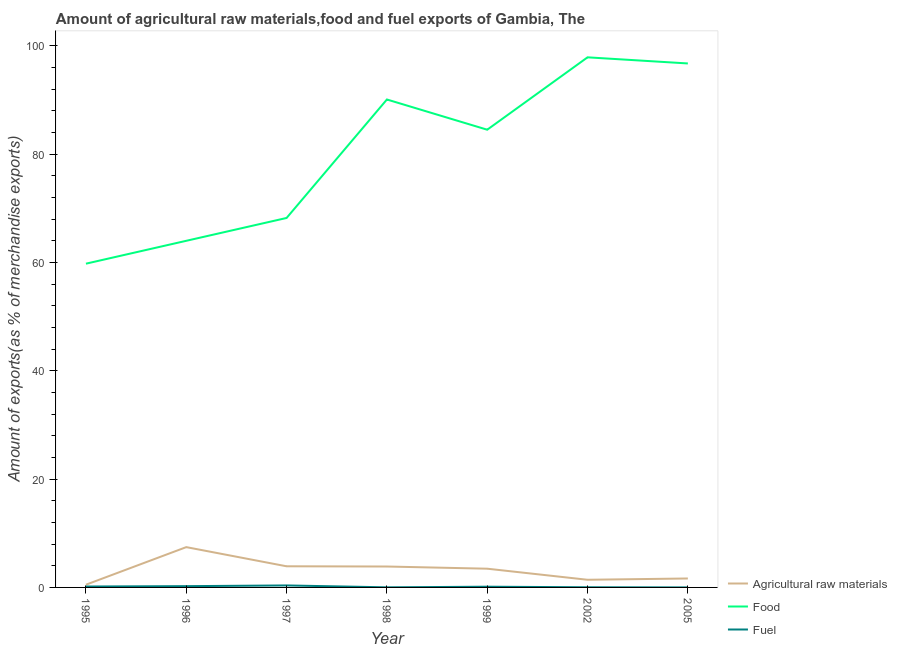Does the line corresponding to percentage of fuel exports intersect with the line corresponding to percentage of food exports?
Give a very brief answer. No. Is the number of lines equal to the number of legend labels?
Make the answer very short. Yes. What is the percentage of fuel exports in 1995?
Keep it short and to the point. 0.17. Across all years, what is the maximum percentage of fuel exports?
Your answer should be compact. 0.37. Across all years, what is the minimum percentage of raw materials exports?
Give a very brief answer. 0.5. In which year was the percentage of raw materials exports maximum?
Make the answer very short. 1996. What is the total percentage of raw materials exports in the graph?
Offer a terse response. 22.23. What is the difference between the percentage of fuel exports in 1999 and that in 2002?
Give a very brief answer. 0.1. What is the difference between the percentage of raw materials exports in 1997 and the percentage of food exports in 2002?
Provide a short and direct response. -93.96. What is the average percentage of raw materials exports per year?
Offer a very short reply. 3.18. In the year 2005, what is the difference between the percentage of food exports and percentage of fuel exports?
Offer a very short reply. 96.73. In how many years, is the percentage of fuel exports greater than 76 %?
Offer a very short reply. 0. What is the ratio of the percentage of fuel exports in 1996 to that in 1997?
Your answer should be compact. 0.64. Is the difference between the percentage of raw materials exports in 2002 and 2005 greater than the difference between the percentage of fuel exports in 2002 and 2005?
Offer a very short reply. No. What is the difference between the highest and the second highest percentage of food exports?
Your answer should be compact. 1.13. What is the difference between the highest and the lowest percentage of food exports?
Make the answer very short. 38.1. In how many years, is the percentage of food exports greater than the average percentage of food exports taken over all years?
Ensure brevity in your answer.  4. Is the sum of the percentage of fuel exports in 1997 and 1999 greater than the maximum percentage of raw materials exports across all years?
Make the answer very short. No. Is the percentage of food exports strictly greater than the percentage of fuel exports over the years?
Provide a short and direct response. Yes. How many lines are there?
Offer a terse response. 3. What is the difference between two consecutive major ticks on the Y-axis?
Your response must be concise. 20. Are the values on the major ticks of Y-axis written in scientific E-notation?
Give a very brief answer. No. Does the graph contain any zero values?
Your answer should be very brief. No. Does the graph contain grids?
Make the answer very short. No. How many legend labels are there?
Make the answer very short. 3. What is the title of the graph?
Offer a very short reply. Amount of agricultural raw materials,food and fuel exports of Gambia, The. What is the label or title of the Y-axis?
Keep it short and to the point. Amount of exports(as % of merchandise exports). What is the Amount of exports(as % of merchandise exports) of Agricultural raw materials in 1995?
Make the answer very short. 0.5. What is the Amount of exports(as % of merchandise exports) of Food in 1995?
Offer a very short reply. 59.77. What is the Amount of exports(as % of merchandise exports) in Fuel in 1995?
Make the answer very short. 0.17. What is the Amount of exports(as % of merchandise exports) of Agricultural raw materials in 1996?
Keep it short and to the point. 7.44. What is the Amount of exports(as % of merchandise exports) in Food in 1996?
Your answer should be compact. 63.99. What is the Amount of exports(as % of merchandise exports) in Fuel in 1996?
Your response must be concise. 0.24. What is the Amount of exports(as % of merchandise exports) in Agricultural raw materials in 1997?
Offer a very short reply. 3.9. What is the Amount of exports(as % of merchandise exports) of Food in 1997?
Provide a short and direct response. 68.21. What is the Amount of exports(as % of merchandise exports) in Fuel in 1997?
Your response must be concise. 0.37. What is the Amount of exports(as % of merchandise exports) of Agricultural raw materials in 1998?
Your answer should be compact. 3.86. What is the Amount of exports(as % of merchandise exports) in Food in 1998?
Offer a very short reply. 90.08. What is the Amount of exports(as % of merchandise exports) in Fuel in 1998?
Offer a very short reply. 0.02. What is the Amount of exports(as % of merchandise exports) in Agricultural raw materials in 1999?
Provide a short and direct response. 3.46. What is the Amount of exports(as % of merchandise exports) in Food in 1999?
Offer a very short reply. 84.5. What is the Amount of exports(as % of merchandise exports) in Fuel in 1999?
Ensure brevity in your answer.  0.13. What is the Amount of exports(as % of merchandise exports) in Agricultural raw materials in 2002?
Ensure brevity in your answer.  1.41. What is the Amount of exports(as % of merchandise exports) in Food in 2002?
Give a very brief answer. 97.86. What is the Amount of exports(as % of merchandise exports) of Fuel in 2002?
Offer a very short reply. 0.03. What is the Amount of exports(as % of merchandise exports) in Agricultural raw materials in 2005?
Your response must be concise. 1.65. What is the Amount of exports(as % of merchandise exports) in Food in 2005?
Your answer should be compact. 96.73. What is the Amount of exports(as % of merchandise exports) of Fuel in 2005?
Ensure brevity in your answer.  0. Across all years, what is the maximum Amount of exports(as % of merchandise exports) in Agricultural raw materials?
Provide a succinct answer. 7.44. Across all years, what is the maximum Amount of exports(as % of merchandise exports) in Food?
Your answer should be compact. 97.86. Across all years, what is the maximum Amount of exports(as % of merchandise exports) in Fuel?
Keep it short and to the point. 0.37. Across all years, what is the minimum Amount of exports(as % of merchandise exports) in Agricultural raw materials?
Make the answer very short. 0.5. Across all years, what is the minimum Amount of exports(as % of merchandise exports) of Food?
Your answer should be very brief. 59.77. Across all years, what is the minimum Amount of exports(as % of merchandise exports) of Fuel?
Provide a succinct answer. 0. What is the total Amount of exports(as % of merchandise exports) of Agricultural raw materials in the graph?
Ensure brevity in your answer.  22.23. What is the total Amount of exports(as % of merchandise exports) of Food in the graph?
Give a very brief answer. 561.15. What is the total Amount of exports(as % of merchandise exports) of Fuel in the graph?
Give a very brief answer. 0.96. What is the difference between the Amount of exports(as % of merchandise exports) of Agricultural raw materials in 1995 and that in 1996?
Offer a very short reply. -6.94. What is the difference between the Amount of exports(as % of merchandise exports) in Food in 1995 and that in 1996?
Offer a terse response. -4.22. What is the difference between the Amount of exports(as % of merchandise exports) in Fuel in 1995 and that in 1996?
Offer a very short reply. -0.07. What is the difference between the Amount of exports(as % of merchandise exports) of Agricultural raw materials in 1995 and that in 1997?
Ensure brevity in your answer.  -3.4. What is the difference between the Amount of exports(as % of merchandise exports) of Food in 1995 and that in 1997?
Keep it short and to the point. -8.44. What is the difference between the Amount of exports(as % of merchandise exports) of Fuel in 1995 and that in 1997?
Ensure brevity in your answer.  -0.2. What is the difference between the Amount of exports(as % of merchandise exports) of Agricultural raw materials in 1995 and that in 1998?
Your answer should be very brief. -3.36. What is the difference between the Amount of exports(as % of merchandise exports) of Food in 1995 and that in 1998?
Give a very brief answer. -30.31. What is the difference between the Amount of exports(as % of merchandise exports) of Fuel in 1995 and that in 1998?
Make the answer very short. 0.15. What is the difference between the Amount of exports(as % of merchandise exports) of Agricultural raw materials in 1995 and that in 1999?
Your answer should be very brief. -2.95. What is the difference between the Amount of exports(as % of merchandise exports) of Food in 1995 and that in 1999?
Offer a terse response. -24.73. What is the difference between the Amount of exports(as % of merchandise exports) in Fuel in 1995 and that in 1999?
Offer a very short reply. 0.04. What is the difference between the Amount of exports(as % of merchandise exports) of Agricultural raw materials in 1995 and that in 2002?
Your response must be concise. -0.91. What is the difference between the Amount of exports(as % of merchandise exports) in Food in 1995 and that in 2002?
Provide a short and direct response. -38.1. What is the difference between the Amount of exports(as % of merchandise exports) in Fuel in 1995 and that in 2002?
Ensure brevity in your answer.  0.14. What is the difference between the Amount of exports(as % of merchandise exports) of Agricultural raw materials in 1995 and that in 2005?
Provide a succinct answer. -1.15. What is the difference between the Amount of exports(as % of merchandise exports) in Food in 1995 and that in 2005?
Your answer should be very brief. -36.97. What is the difference between the Amount of exports(as % of merchandise exports) in Fuel in 1995 and that in 2005?
Give a very brief answer. 0.17. What is the difference between the Amount of exports(as % of merchandise exports) in Agricultural raw materials in 1996 and that in 1997?
Offer a very short reply. 3.54. What is the difference between the Amount of exports(as % of merchandise exports) in Food in 1996 and that in 1997?
Your answer should be compact. -4.22. What is the difference between the Amount of exports(as % of merchandise exports) in Fuel in 1996 and that in 1997?
Offer a very short reply. -0.13. What is the difference between the Amount of exports(as % of merchandise exports) in Agricultural raw materials in 1996 and that in 1998?
Provide a short and direct response. 3.58. What is the difference between the Amount of exports(as % of merchandise exports) in Food in 1996 and that in 1998?
Make the answer very short. -26.09. What is the difference between the Amount of exports(as % of merchandise exports) in Fuel in 1996 and that in 1998?
Your answer should be compact. 0.22. What is the difference between the Amount of exports(as % of merchandise exports) of Agricultural raw materials in 1996 and that in 1999?
Offer a very short reply. 3.98. What is the difference between the Amount of exports(as % of merchandise exports) of Food in 1996 and that in 1999?
Offer a very short reply. -20.51. What is the difference between the Amount of exports(as % of merchandise exports) in Fuel in 1996 and that in 1999?
Ensure brevity in your answer.  0.1. What is the difference between the Amount of exports(as % of merchandise exports) in Agricultural raw materials in 1996 and that in 2002?
Provide a short and direct response. 6.03. What is the difference between the Amount of exports(as % of merchandise exports) of Food in 1996 and that in 2002?
Offer a very short reply. -33.87. What is the difference between the Amount of exports(as % of merchandise exports) of Fuel in 1996 and that in 2002?
Make the answer very short. 0.21. What is the difference between the Amount of exports(as % of merchandise exports) in Agricultural raw materials in 1996 and that in 2005?
Your answer should be very brief. 5.79. What is the difference between the Amount of exports(as % of merchandise exports) in Food in 1996 and that in 2005?
Offer a terse response. -32.74. What is the difference between the Amount of exports(as % of merchandise exports) in Fuel in 1996 and that in 2005?
Your response must be concise. 0.23. What is the difference between the Amount of exports(as % of merchandise exports) of Agricultural raw materials in 1997 and that in 1998?
Your response must be concise. 0.04. What is the difference between the Amount of exports(as % of merchandise exports) in Food in 1997 and that in 1998?
Provide a short and direct response. -21.87. What is the difference between the Amount of exports(as % of merchandise exports) of Fuel in 1997 and that in 1998?
Provide a short and direct response. 0.35. What is the difference between the Amount of exports(as % of merchandise exports) of Agricultural raw materials in 1997 and that in 1999?
Provide a short and direct response. 0.44. What is the difference between the Amount of exports(as % of merchandise exports) in Food in 1997 and that in 1999?
Provide a succinct answer. -16.29. What is the difference between the Amount of exports(as % of merchandise exports) in Fuel in 1997 and that in 1999?
Make the answer very short. 0.23. What is the difference between the Amount of exports(as % of merchandise exports) in Agricultural raw materials in 1997 and that in 2002?
Your answer should be very brief. 2.49. What is the difference between the Amount of exports(as % of merchandise exports) in Food in 1997 and that in 2002?
Provide a short and direct response. -29.66. What is the difference between the Amount of exports(as % of merchandise exports) in Fuel in 1997 and that in 2002?
Make the answer very short. 0.34. What is the difference between the Amount of exports(as % of merchandise exports) in Agricultural raw materials in 1997 and that in 2005?
Make the answer very short. 2.25. What is the difference between the Amount of exports(as % of merchandise exports) in Food in 1997 and that in 2005?
Offer a very short reply. -28.53. What is the difference between the Amount of exports(as % of merchandise exports) of Fuel in 1997 and that in 2005?
Your answer should be compact. 0.36. What is the difference between the Amount of exports(as % of merchandise exports) of Agricultural raw materials in 1998 and that in 1999?
Offer a terse response. 0.4. What is the difference between the Amount of exports(as % of merchandise exports) of Food in 1998 and that in 1999?
Your response must be concise. 5.58. What is the difference between the Amount of exports(as % of merchandise exports) of Fuel in 1998 and that in 1999?
Ensure brevity in your answer.  -0.12. What is the difference between the Amount of exports(as % of merchandise exports) of Agricultural raw materials in 1998 and that in 2002?
Provide a short and direct response. 2.45. What is the difference between the Amount of exports(as % of merchandise exports) in Food in 1998 and that in 2002?
Make the answer very short. -7.78. What is the difference between the Amount of exports(as % of merchandise exports) of Fuel in 1998 and that in 2002?
Provide a short and direct response. -0.01. What is the difference between the Amount of exports(as % of merchandise exports) of Agricultural raw materials in 1998 and that in 2005?
Provide a short and direct response. 2.21. What is the difference between the Amount of exports(as % of merchandise exports) of Food in 1998 and that in 2005?
Ensure brevity in your answer.  -6.65. What is the difference between the Amount of exports(as % of merchandise exports) in Fuel in 1998 and that in 2005?
Provide a succinct answer. 0.01. What is the difference between the Amount of exports(as % of merchandise exports) of Agricultural raw materials in 1999 and that in 2002?
Give a very brief answer. 2.04. What is the difference between the Amount of exports(as % of merchandise exports) of Food in 1999 and that in 2002?
Offer a very short reply. -13.36. What is the difference between the Amount of exports(as % of merchandise exports) in Fuel in 1999 and that in 2002?
Offer a terse response. 0.1. What is the difference between the Amount of exports(as % of merchandise exports) in Agricultural raw materials in 1999 and that in 2005?
Make the answer very short. 1.81. What is the difference between the Amount of exports(as % of merchandise exports) in Food in 1999 and that in 2005?
Your answer should be very brief. -12.23. What is the difference between the Amount of exports(as % of merchandise exports) in Fuel in 1999 and that in 2005?
Your response must be concise. 0.13. What is the difference between the Amount of exports(as % of merchandise exports) in Agricultural raw materials in 2002 and that in 2005?
Offer a terse response. -0.24. What is the difference between the Amount of exports(as % of merchandise exports) in Food in 2002 and that in 2005?
Provide a succinct answer. 1.13. What is the difference between the Amount of exports(as % of merchandise exports) of Fuel in 2002 and that in 2005?
Ensure brevity in your answer.  0.03. What is the difference between the Amount of exports(as % of merchandise exports) of Agricultural raw materials in 1995 and the Amount of exports(as % of merchandise exports) of Food in 1996?
Make the answer very short. -63.49. What is the difference between the Amount of exports(as % of merchandise exports) of Agricultural raw materials in 1995 and the Amount of exports(as % of merchandise exports) of Fuel in 1996?
Offer a very short reply. 0.27. What is the difference between the Amount of exports(as % of merchandise exports) in Food in 1995 and the Amount of exports(as % of merchandise exports) in Fuel in 1996?
Your answer should be very brief. 59.53. What is the difference between the Amount of exports(as % of merchandise exports) of Agricultural raw materials in 1995 and the Amount of exports(as % of merchandise exports) of Food in 1997?
Offer a very short reply. -67.7. What is the difference between the Amount of exports(as % of merchandise exports) of Agricultural raw materials in 1995 and the Amount of exports(as % of merchandise exports) of Fuel in 1997?
Your answer should be very brief. 0.14. What is the difference between the Amount of exports(as % of merchandise exports) in Food in 1995 and the Amount of exports(as % of merchandise exports) in Fuel in 1997?
Give a very brief answer. 59.4. What is the difference between the Amount of exports(as % of merchandise exports) of Agricultural raw materials in 1995 and the Amount of exports(as % of merchandise exports) of Food in 1998?
Provide a succinct answer. -89.58. What is the difference between the Amount of exports(as % of merchandise exports) in Agricultural raw materials in 1995 and the Amount of exports(as % of merchandise exports) in Fuel in 1998?
Offer a very short reply. 0.49. What is the difference between the Amount of exports(as % of merchandise exports) in Food in 1995 and the Amount of exports(as % of merchandise exports) in Fuel in 1998?
Offer a very short reply. 59.75. What is the difference between the Amount of exports(as % of merchandise exports) of Agricultural raw materials in 1995 and the Amount of exports(as % of merchandise exports) of Food in 1999?
Provide a succinct answer. -84. What is the difference between the Amount of exports(as % of merchandise exports) of Agricultural raw materials in 1995 and the Amount of exports(as % of merchandise exports) of Fuel in 1999?
Make the answer very short. 0.37. What is the difference between the Amount of exports(as % of merchandise exports) in Food in 1995 and the Amount of exports(as % of merchandise exports) in Fuel in 1999?
Offer a very short reply. 59.64. What is the difference between the Amount of exports(as % of merchandise exports) in Agricultural raw materials in 1995 and the Amount of exports(as % of merchandise exports) in Food in 2002?
Your response must be concise. -97.36. What is the difference between the Amount of exports(as % of merchandise exports) of Agricultural raw materials in 1995 and the Amount of exports(as % of merchandise exports) of Fuel in 2002?
Your answer should be compact. 0.47. What is the difference between the Amount of exports(as % of merchandise exports) in Food in 1995 and the Amount of exports(as % of merchandise exports) in Fuel in 2002?
Your answer should be very brief. 59.74. What is the difference between the Amount of exports(as % of merchandise exports) in Agricultural raw materials in 1995 and the Amount of exports(as % of merchandise exports) in Food in 2005?
Your response must be concise. -96.23. What is the difference between the Amount of exports(as % of merchandise exports) in Agricultural raw materials in 1995 and the Amount of exports(as % of merchandise exports) in Fuel in 2005?
Provide a short and direct response. 0.5. What is the difference between the Amount of exports(as % of merchandise exports) in Food in 1995 and the Amount of exports(as % of merchandise exports) in Fuel in 2005?
Provide a succinct answer. 59.77. What is the difference between the Amount of exports(as % of merchandise exports) in Agricultural raw materials in 1996 and the Amount of exports(as % of merchandise exports) in Food in 1997?
Keep it short and to the point. -60.77. What is the difference between the Amount of exports(as % of merchandise exports) in Agricultural raw materials in 1996 and the Amount of exports(as % of merchandise exports) in Fuel in 1997?
Make the answer very short. 7.07. What is the difference between the Amount of exports(as % of merchandise exports) of Food in 1996 and the Amount of exports(as % of merchandise exports) of Fuel in 1997?
Offer a terse response. 63.62. What is the difference between the Amount of exports(as % of merchandise exports) of Agricultural raw materials in 1996 and the Amount of exports(as % of merchandise exports) of Food in 1998?
Offer a terse response. -82.64. What is the difference between the Amount of exports(as % of merchandise exports) in Agricultural raw materials in 1996 and the Amount of exports(as % of merchandise exports) in Fuel in 1998?
Your response must be concise. 7.42. What is the difference between the Amount of exports(as % of merchandise exports) of Food in 1996 and the Amount of exports(as % of merchandise exports) of Fuel in 1998?
Make the answer very short. 63.97. What is the difference between the Amount of exports(as % of merchandise exports) in Agricultural raw materials in 1996 and the Amount of exports(as % of merchandise exports) in Food in 1999?
Offer a terse response. -77.06. What is the difference between the Amount of exports(as % of merchandise exports) in Agricultural raw materials in 1996 and the Amount of exports(as % of merchandise exports) in Fuel in 1999?
Ensure brevity in your answer.  7.31. What is the difference between the Amount of exports(as % of merchandise exports) of Food in 1996 and the Amount of exports(as % of merchandise exports) of Fuel in 1999?
Offer a terse response. 63.86. What is the difference between the Amount of exports(as % of merchandise exports) of Agricultural raw materials in 1996 and the Amount of exports(as % of merchandise exports) of Food in 2002?
Keep it short and to the point. -90.43. What is the difference between the Amount of exports(as % of merchandise exports) in Agricultural raw materials in 1996 and the Amount of exports(as % of merchandise exports) in Fuel in 2002?
Make the answer very short. 7.41. What is the difference between the Amount of exports(as % of merchandise exports) in Food in 1996 and the Amount of exports(as % of merchandise exports) in Fuel in 2002?
Offer a terse response. 63.96. What is the difference between the Amount of exports(as % of merchandise exports) in Agricultural raw materials in 1996 and the Amount of exports(as % of merchandise exports) in Food in 2005?
Offer a terse response. -89.29. What is the difference between the Amount of exports(as % of merchandise exports) of Agricultural raw materials in 1996 and the Amount of exports(as % of merchandise exports) of Fuel in 2005?
Ensure brevity in your answer.  7.44. What is the difference between the Amount of exports(as % of merchandise exports) in Food in 1996 and the Amount of exports(as % of merchandise exports) in Fuel in 2005?
Provide a short and direct response. 63.99. What is the difference between the Amount of exports(as % of merchandise exports) in Agricultural raw materials in 1997 and the Amount of exports(as % of merchandise exports) in Food in 1998?
Ensure brevity in your answer.  -86.18. What is the difference between the Amount of exports(as % of merchandise exports) of Agricultural raw materials in 1997 and the Amount of exports(as % of merchandise exports) of Fuel in 1998?
Offer a very short reply. 3.89. What is the difference between the Amount of exports(as % of merchandise exports) in Food in 1997 and the Amount of exports(as % of merchandise exports) in Fuel in 1998?
Provide a short and direct response. 68.19. What is the difference between the Amount of exports(as % of merchandise exports) in Agricultural raw materials in 1997 and the Amount of exports(as % of merchandise exports) in Food in 1999?
Offer a terse response. -80.6. What is the difference between the Amount of exports(as % of merchandise exports) in Agricultural raw materials in 1997 and the Amount of exports(as % of merchandise exports) in Fuel in 1999?
Offer a terse response. 3.77. What is the difference between the Amount of exports(as % of merchandise exports) of Food in 1997 and the Amount of exports(as % of merchandise exports) of Fuel in 1999?
Keep it short and to the point. 68.08. What is the difference between the Amount of exports(as % of merchandise exports) in Agricultural raw materials in 1997 and the Amount of exports(as % of merchandise exports) in Food in 2002?
Your answer should be compact. -93.96. What is the difference between the Amount of exports(as % of merchandise exports) of Agricultural raw materials in 1997 and the Amount of exports(as % of merchandise exports) of Fuel in 2002?
Provide a succinct answer. 3.87. What is the difference between the Amount of exports(as % of merchandise exports) in Food in 1997 and the Amount of exports(as % of merchandise exports) in Fuel in 2002?
Ensure brevity in your answer.  68.18. What is the difference between the Amount of exports(as % of merchandise exports) in Agricultural raw materials in 1997 and the Amount of exports(as % of merchandise exports) in Food in 2005?
Offer a terse response. -92.83. What is the difference between the Amount of exports(as % of merchandise exports) in Agricultural raw materials in 1997 and the Amount of exports(as % of merchandise exports) in Fuel in 2005?
Your answer should be very brief. 3.9. What is the difference between the Amount of exports(as % of merchandise exports) of Food in 1997 and the Amount of exports(as % of merchandise exports) of Fuel in 2005?
Offer a very short reply. 68.21. What is the difference between the Amount of exports(as % of merchandise exports) of Agricultural raw materials in 1998 and the Amount of exports(as % of merchandise exports) of Food in 1999?
Your response must be concise. -80.64. What is the difference between the Amount of exports(as % of merchandise exports) in Agricultural raw materials in 1998 and the Amount of exports(as % of merchandise exports) in Fuel in 1999?
Offer a very short reply. 3.73. What is the difference between the Amount of exports(as % of merchandise exports) in Food in 1998 and the Amount of exports(as % of merchandise exports) in Fuel in 1999?
Provide a succinct answer. 89.95. What is the difference between the Amount of exports(as % of merchandise exports) in Agricultural raw materials in 1998 and the Amount of exports(as % of merchandise exports) in Food in 2002?
Offer a terse response. -94. What is the difference between the Amount of exports(as % of merchandise exports) of Agricultural raw materials in 1998 and the Amount of exports(as % of merchandise exports) of Fuel in 2002?
Offer a terse response. 3.83. What is the difference between the Amount of exports(as % of merchandise exports) of Food in 1998 and the Amount of exports(as % of merchandise exports) of Fuel in 2002?
Your answer should be compact. 90.05. What is the difference between the Amount of exports(as % of merchandise exports) of Agricultural raw materials in 1998 and the Amount of exports(as % of merchandise exports) of Food in 2005?
Your answer should be compact. -92.87. What is the difference between the Amount of exports(as % of merchandise exports) in Agricultural raw materials in 1998 and the Amount of exports(as % of merchandise exports) in Fuel in 2005?
Your answer should be very brief. 3.86. What is the difference between the Amount of exports(as % of merchandise exports) of Food in 1998 and the Amount of exports(as % of merchandise exports) of Fuel in 2005?
Provide a succinct answer. 90.08. What is the difference between the Amount of exports(as % of merchandise exports) in Agricultural raw materials in 1999 and the Amount of exports(as % of merchandise exports) in Food in 2002?
Your answer should be very brief. -94.41. What is the difference between the Amount of exports(as % of merchandise exports) in Agricultural raw materials in 1999 and the Amount of exports(as % of merchandise exports) in Fuel in 2002?
Offer a terse response. 3.43. What is the difference between the Amount of exports(as % of merchandise exports) of Food in 1999 and the Amount of exports(as % of merchandise exports) of Fuel in 2002?
Your response must be concise. 84.47. What is the difference between the Amount of exports(as % of merchandise exports) in Agricultural raw materials in 1999 and the Amount of exports(as % of merchandise exports) in Food in 2005?
Your answer should be very brief. -93.28. What is the difference between the Amount of exports(as % of merchandise exports) of Agricultural raw materials in 1999 and the Amount of exports(as % of merchandise exports) of Fuel in 2005?
Your response must be concise. 3.46. What is the difference between the Amount of exports(as % of merchandise exports) of Food in 1999 and the Amount of exports(as % of merchandise exports) of Fuel in 2005?
Keep it short and to the point. 84.5. What is the difference between the Amount of exports(as % of merchandise exports) in Agricultural raw materials in 2002 and the Amount of exports(as % of merchandise exports) in Food in 2005?
Your response must be concise. -95.32. What is the difference between the Amount of exports(as % of merchandise exports) in Agricultural raw materials in 2002 and the Amount of exports(as % of merchandise exports) in Fuel in 2005?
Make the answer very short. 1.41. What is the difference between the Amount of exports(as % of merchandise exports) in Food in 2002 and the Amount of exports(as % of merchandise exports) in Fuel in 2005?
Ensure brevity in your answer.  97.86. What is the average Amount of exports(as % of merchandise exports) of Agricultural raw materials per year?
Offer a terse response. 3.18. What is the average Amount of exports(as % of merchandise exports) of Food per year?
Keep it short and to the point. 80.16. What is the average Amount of exports(as % of merchandise exports) of Fuel per year?
Offer a very short reply. 0.14. In the year 1995, what is the difference between the Amount of exports(as % of merchandise exports) of Agricultural raw materials and Amount of exports(as % of merchandise exports) of Food?
Provide a succinct answer. -59.26. In the year 1995, what is the difference between the Amount of exports(as % of merchandise exports) of Agricultural raw materials and Amount of exports(as % of merchandise exports) of Fuel?
Your response must be concise. 0.34. In the year 1995, what is the difference between the Amount of exports(as % of merchandise exports) of Food and Amount of exports(as % of merchandise exports) of Fuel?
Provide a succinct answer. 59.6. In the year 1996, what is the difference between the Amount of exports(as % of merchandise exports) of Agricultural raw materials and Amount of exports(as % of merchandise exports) of Food?
Give a very brief answer. -56.55. In the year 1996, what is the difference between the Amount of exports(as % of merchandise exports) in Agricultural raw materials and Amount of exports(as % of merchandise exports) in Fuel?
Provide a succinct answer. 7.2. In the year 1996, what is the difference between the Amount of exports(as % of merchandise exports) of Food and Amount of exports(as % of merchandise exports) of Fuel?
Offer a very short reply. 63.76. In the year 1997, what is the difference between the Amount of exports(as % of merchandise exports) of Agricultural raw materials and Amount of exports(as % of merchandise exports) of Food?
Provide a short and direct response. -64.31. In the year 1997, what is the difference between the Amount of exports(as % of merchandise exports) of Agricultural raw materials and Amount of exports(as % of merchandise exports) of Fuel?
Your answer should be compact. 3.54. In the year 1997, what is the difference between the Amount of exports(as % of merchandise exports) of Food and Amount of exports(as % of merchandise exports) of Fuel?
Your answer should be compact. 67.84. In the year 1998, what is the difference between the Amount of exports(as % of merchandise exports) of Agricultural raw materials and Amount of exports(as % of merchandise exports) of Food?
Ensure brevity in your answer.  -86.22. In the year 1998, what is the difference between the Amount of exports(as % of merchandise exports) in Agricultural raw materials and Amount of exports(as % of merchandise exports) in Fuel?
Offer a terse response. 3.84. In the year 1998, what is the difference between the Amount of exports(as % of merchandise exports) of Food and Amount of exports(as % of merchandise exports) of Fuel?
Provide a succinct answer. 90.06. In the year 1999, what is the difference between the Amount of exports(as % of merchandise exports) of Agricultural raw materials and Amount of exports(as % of merchandise exports) of Food?
Your answer should be very brief. -81.04. In the year 1999, what is the difference between the Amount of exports(as % of merchandise exports) of Agricultural raw materials and Amount of exports(as % of merchandise exports) of Fuel?
Offer a terse response. 3.33. In the year 1999, what is the difference between the Amount of exports(as % of merchandise exports) in Food and Amount of exports(as % of merchandise exports) in Fuel?
Provide a short and direct response. 84.37. In the year 2002, what is the difference between the Amount of exports(as % of merchandise exports) in Agricultural raw materials and Amount of exports(as % of merchandise exports) in Food?
Make the answer very short. -96.45. In the year 2002, what is the difference between the Amount of exports(as % of merchandise exports) in Agricultural raw materials and Amount of exports(as % of merchandise exports) in Fuel?
Provide a short and direct response. 1.38. In the year 2002, what is the difference between the Amount of exports(as % of merchandise exports) of Food and Amount of exports(as % of merchandise exports) of Fuel?
Your answer should be very brief. 97.83. In the year 2005, what is the difference between the Amount of exports(as % of merchandise exports) of Agricultural raw materials and Amount of exports(as % of merchandise exports) of Food?
Keep it short and to the point. -95.08. In the year 2005, what is the difference between the Amount of exports(as % of merchandise exports) of Agricultural raw materials and Amount of exports(as % of merchandise exports) of Fuel?
Offer a very short reply. 1.65. In the year 2005, what is the difference between the Amount of exports(as % of merchandise exports) of Food and Amount of exports(as % of merchandise exports) of Fuel?
Provide a short and direct response. 96.73. What is the ratio of the Amount of exports(as % of merchandise exports) in Agricultural raw materials in 1995 to that in 1996?
Offer a terse response. 0.07. What is the ratio of the Amount of exports(as % of merchandise exports) of Food in 1995 to that in 1996?
Your answer should be compact. 0.93. What is the ratio of the Amount of exports(as % of merchandise exports) of Fuel in 1995 to that in 1996?
Make the answer very short. 0.72. What is the ratio of the Amount of exports(as % of merchandise exports) in Agricultural raw materials in 1995 to that in 1997?
Ensure brevity in your answer.  0.13. What is the ratio of the Amount of exports(as % of merchandise exports) in Food in 1995 to that in 1997?
Offer a very short reply. 0.88. What is the ratio of the Amount of exports(as % of merchandise exports) in Fuel in 1995 to that in 1997?
Offer a terse response. 0.46. What is the ratio of the Amount of exports(as % of merchandise exports) in Agricultural raw materials in 1995 to that in 1998?
Give a very brief answer. 0.13. What is the ratio of the Amount of exports(as % of merchandise exports) of Food in 1995 to that in 1998?
Give a very brief answer. 0.66. What is the ratio of the Amount of exports(as % of merchandise exports) of Fuel in 1995 to that in 1998?
Keep it short and to the point. 9.74. What is the ratio of the Amount of exports(as % of merchandise exports) of Agricultural raw materials in 1995 to that in 1999?
Offer a terse response. 0.15. What is the ratio of the Amount of exports(as % of merchandise exports) of Food in 1995 to that in 1999?
Provide a short and direct response. 0.71. What is the ratio of the Amount of exports(as % of merchandise exports) in Fuel in 1995 to that in 1999?
Provide a short and direct response. 1.28. What is the ratio of the Amount of exports(as % of merchandise exports) of Agricultural raw materials in 1995 to that in 2002?
Offer a very short reply. 0.36. What is the ratio of the Amount of exports(as % of merchandise exports) of Food in 1995 to that in 2002?
Offer a terse response. 0.61. What is the ratio of the Amount of exports(as % of merchandise exports) of Fuel in 1995 to that in 2002?
Provide a short and direct response. 5.57. What is the ratio of the Amount of exports(as % of merchandise exports) of Agricultural raw materials in 1995 to that in 2005?
Offer a very short reply. 0.31. What is the ratio of the Amount of exports(as % of merchandise exports) in Food in 1995 to that in 2005?
Your response must be concise. 0.62. What is the ratio of the Amount of exports(as % of merchandise exports) of Fuel in 1995 to that in 2005?
Your response must be concise. 54.8. What is the ratio of the Amount of exports(as % of merchandise exports) of Agricultural raw materials in 1996 to that in 1997?
Offer a terse response. 1.91. What is the ratio of the Amount of exports(as % of merchandise exports) in Food in 1996 to that in 1997?
Your response must be concise. 0.94. What is the ratio of the Amount of exports(as % of merchandise exports) in Fuel in 1996 to that in 1997?
Your response must be concise. 0.64. What is the ratio of the Amount of exports(as % of merchandise exports) of Agricultural raw materials in 1996 to that in 1998?
Provide a succinct answer. 1.93. What is the ratio of the Amount of exports(as % of merchandise exports) in Food in 1996 to that in 1998?
Keep it short and to the point. 0.71. What is the ratio of the Amount of exports(as % of merchandise exports) of Fuel in 1996 to that in 1998?
Your response must be concise. 13.55. What is the ratio of the Amount of exports(as % of merchandise exports) of Agricultural raw materials in 1996 to that in 1999?
Provide a succinct answer. 2.15. What is the ratio of the Amount of exports(as % of merchandise exports) in Food in 1996 to that in 1999?
Give a very brief answer. 0.76. What is the ratio of the Amount of exports(as % of merchandise exports) in Fuel in 1996 to that in 1999?
Give a very brief answer. 1.78. What is the ratio of the Amount of exports(as % of merchandise exports) of Agricultural raw materials in 1996 to that in 2002?
Your answer should be very brief. 5.26. What is the ratio of the Amount of exports(as % of merchandise exports) of Food in 1996 to that in 2002?
Provide a short and direct response. 0.65. What is the ratio of the Amount of exports(as % of merchandise exports) in Fuel in 1996 to that in 2002?
Provide a succinct answer. 7.75. What is the ratio of the Amount of exports(as % of merchandise exports) of Agricultural raw materials in 1996 to that in 2005?
Provide a short and direct response. 4.51. What is the ratio of the Amount of exports(as % of merchandise exports) in Food in 1996 to that in 2005?
Your answer should be compact. 0.66. What is the ratio of the Amount of exports(as % of merchandise exports) of Fuel in 1996 to that in 2005?
Provide a succinct answer. 76.27. What is the ratio of the Amount of exports(as % of merchandise exports) in Agricultural raw materials in 1997 to that in 1998?
Make the answer very short. 1.01. What is the ratio of the Amount of exports(as % of merchandise exports) in Food in 1997 to that in 1998?
Make the answer very short. 0.76. What is the ratio of the Amount of exports(as % of merchandise exports) in Fuel in 1997 to that in 1998?
Provide a short and direct response. 21.12. What is the ratio of the Amount of exports(as % of merchandise exports) in Agricultural raw materials in 1997 to that in 1999?
Your answer should be very brief. 1.13. What is the ratio of the Amount of exports(as % of merchandise exports) of Food in 1997 to that in 1999?
Your answer should be very brief. 0.81. What is the ratio of the Amount of exports(as % of merchandise exports) of Fuel in 1997 to that in 1999?
Give a very brief answer. 2.77. What is the ratio of the Amount of exports(as % of merchandise exports) of Agricultural raw materials in 1997 to that in 2002?
Keep it short and to the point. 2.76. What is the ratio of the Amount of exports(as % of merchandise exports) in Food in 1997 to that in 2002?
Your answer should be compact. 0.7. What is the ratio of the Amount of exports(as % of merchandise exports) of Fuel in 1997 to that in 2002?
Your response must be concise. 12.07. What is the ratio of the Amount of exports(as % of merchandise exports) of Agricultural raw materials in 1997 to that in 2005?
Provide a short and direct response. 2.36. What is the ratio of the Amount of exports(as % of merchandise exports) in Food in 1997 to that in 2005?
Keep it short and to the point. 0.71. What is the ratio of the Amount of exports(as % of merchandise exports) of Fuel in 1997 to that in 2005?
Provide a short and direct response. 118.85. What is the ratio of the Amount of exports(as % of merchandise exports) in Agricultural raw materials in 1998 to that in 1999?
Provide a succinct answer. 1.12. What is the ratio of the Amount of exports(as % of merchandise exports) of Food in 1998 to that in 1999?
Your answer should be compact. 1.07. What is the ratio of the Amount of exports(as % of merchandise exports) in Fuel in 1998 to that in 1999?
Your answer should be very brief. 0.13. What is the ratio of the Amount of exports(as % of merchandise exports) in Agricultural raw materials in 1998 to that in 2002?
Your response must be concise. 2.73. What is the ratio of the Amount of exports(as % of merchandise exports) in Food in 1998 to that in 2002?
Ensure brevity in your answer.  0.92. What is the ratio of the Amount of exports(as % of merchandise exports) of Fuel in 1998 to that in 2002?
Provide a succinct answer. 0.57. What is the ratio of the Amount of exports(as % of merchandise exports) of Agricultural raw materials in 1998 to that in 2005?
Give a very brief answer. 2.34. What is the ratio of the Amount of exports(as % of merchandise exports) of Food in 1998 to that in 2005?
Your answer should be very brief. 0.93. What is the ratio of the Amount of exports(as % of merchandise exports) in Fuel in 1998 to that in 2005?
Offer a terse response. 5.63. What is the ratio of the Amount of exports(as % of merchandise exports) of Agricultural raw materials in 1999 to that in 2002?
Offer a very short reply. 2.45. What is the ratio of the Amount of exports(as % of merchandise exports) of Food in 1999 to that in 2002?
Offer a very short reply. 0.86. What is the ratio of the Amount of exports(as % of merchandise exports) of Fuel in 1999 to that in 2002?
Make the answer very short. 4.36. What is the ratio of the Amount of exports(as % of merchandise exports) of Agricultural raw materials in 1999 to that in 2005?
Your answer should be very brief. 2.09. What is the ratio of the Amount of exports(as % of merchandise exports) in Food in 1999 to that in 2005?
Provide a succinct answer. 0.87. What is the ratio of the Amount of exports(as % of merchandise exports) of Fuel in 1999 to that in 2005?
Ensure brevity in your answer.  42.96. What is the ratio of the Amount of exports(as % of merchandise exports) of Agricultural raw materials in 2002 to that in 2005?
Make the answer very short. 0.86. What is the ratio of the Amount of exports(as % of merchandise exports) in Food in 2002 to that in 2005?
Offer a very short reply. 1.01. What is the ratio of the Amount of exports(as % of merchandise exports) of Fuel in 2002 to that in 2005?
Your answer should be very brief. 9.84. What is the difference between the highest and the second highest Amount of exports(as % of merchandise exports) in Agricultural raw materials?
Keep it short and to the point. 3.54. What is the difference between the highest and the second highest Amount of exports(as % of merchandise exports) in Food?
Give a very brief answer. 1.13. What is the difference between the highest and the second highest Amount of exports(as % of merchandise exports) of Fuel?
Your answer should be very brief. 0.13. What is the difference between the highest and the lowest Amount of exports(as % of merchandise exports) in Agricultural raw materials?
Your answer should be very brief. 6.94. What is the difference between the highest and the lowest Amount of exports(as % of merchandise exports) in Food?
Keep it short and to the point. 38.1. What is the difference between the highest and the lowest Amount of exports(as % of merchandise exports) in Fuel?
Your answer should be very brief. 0.36. 